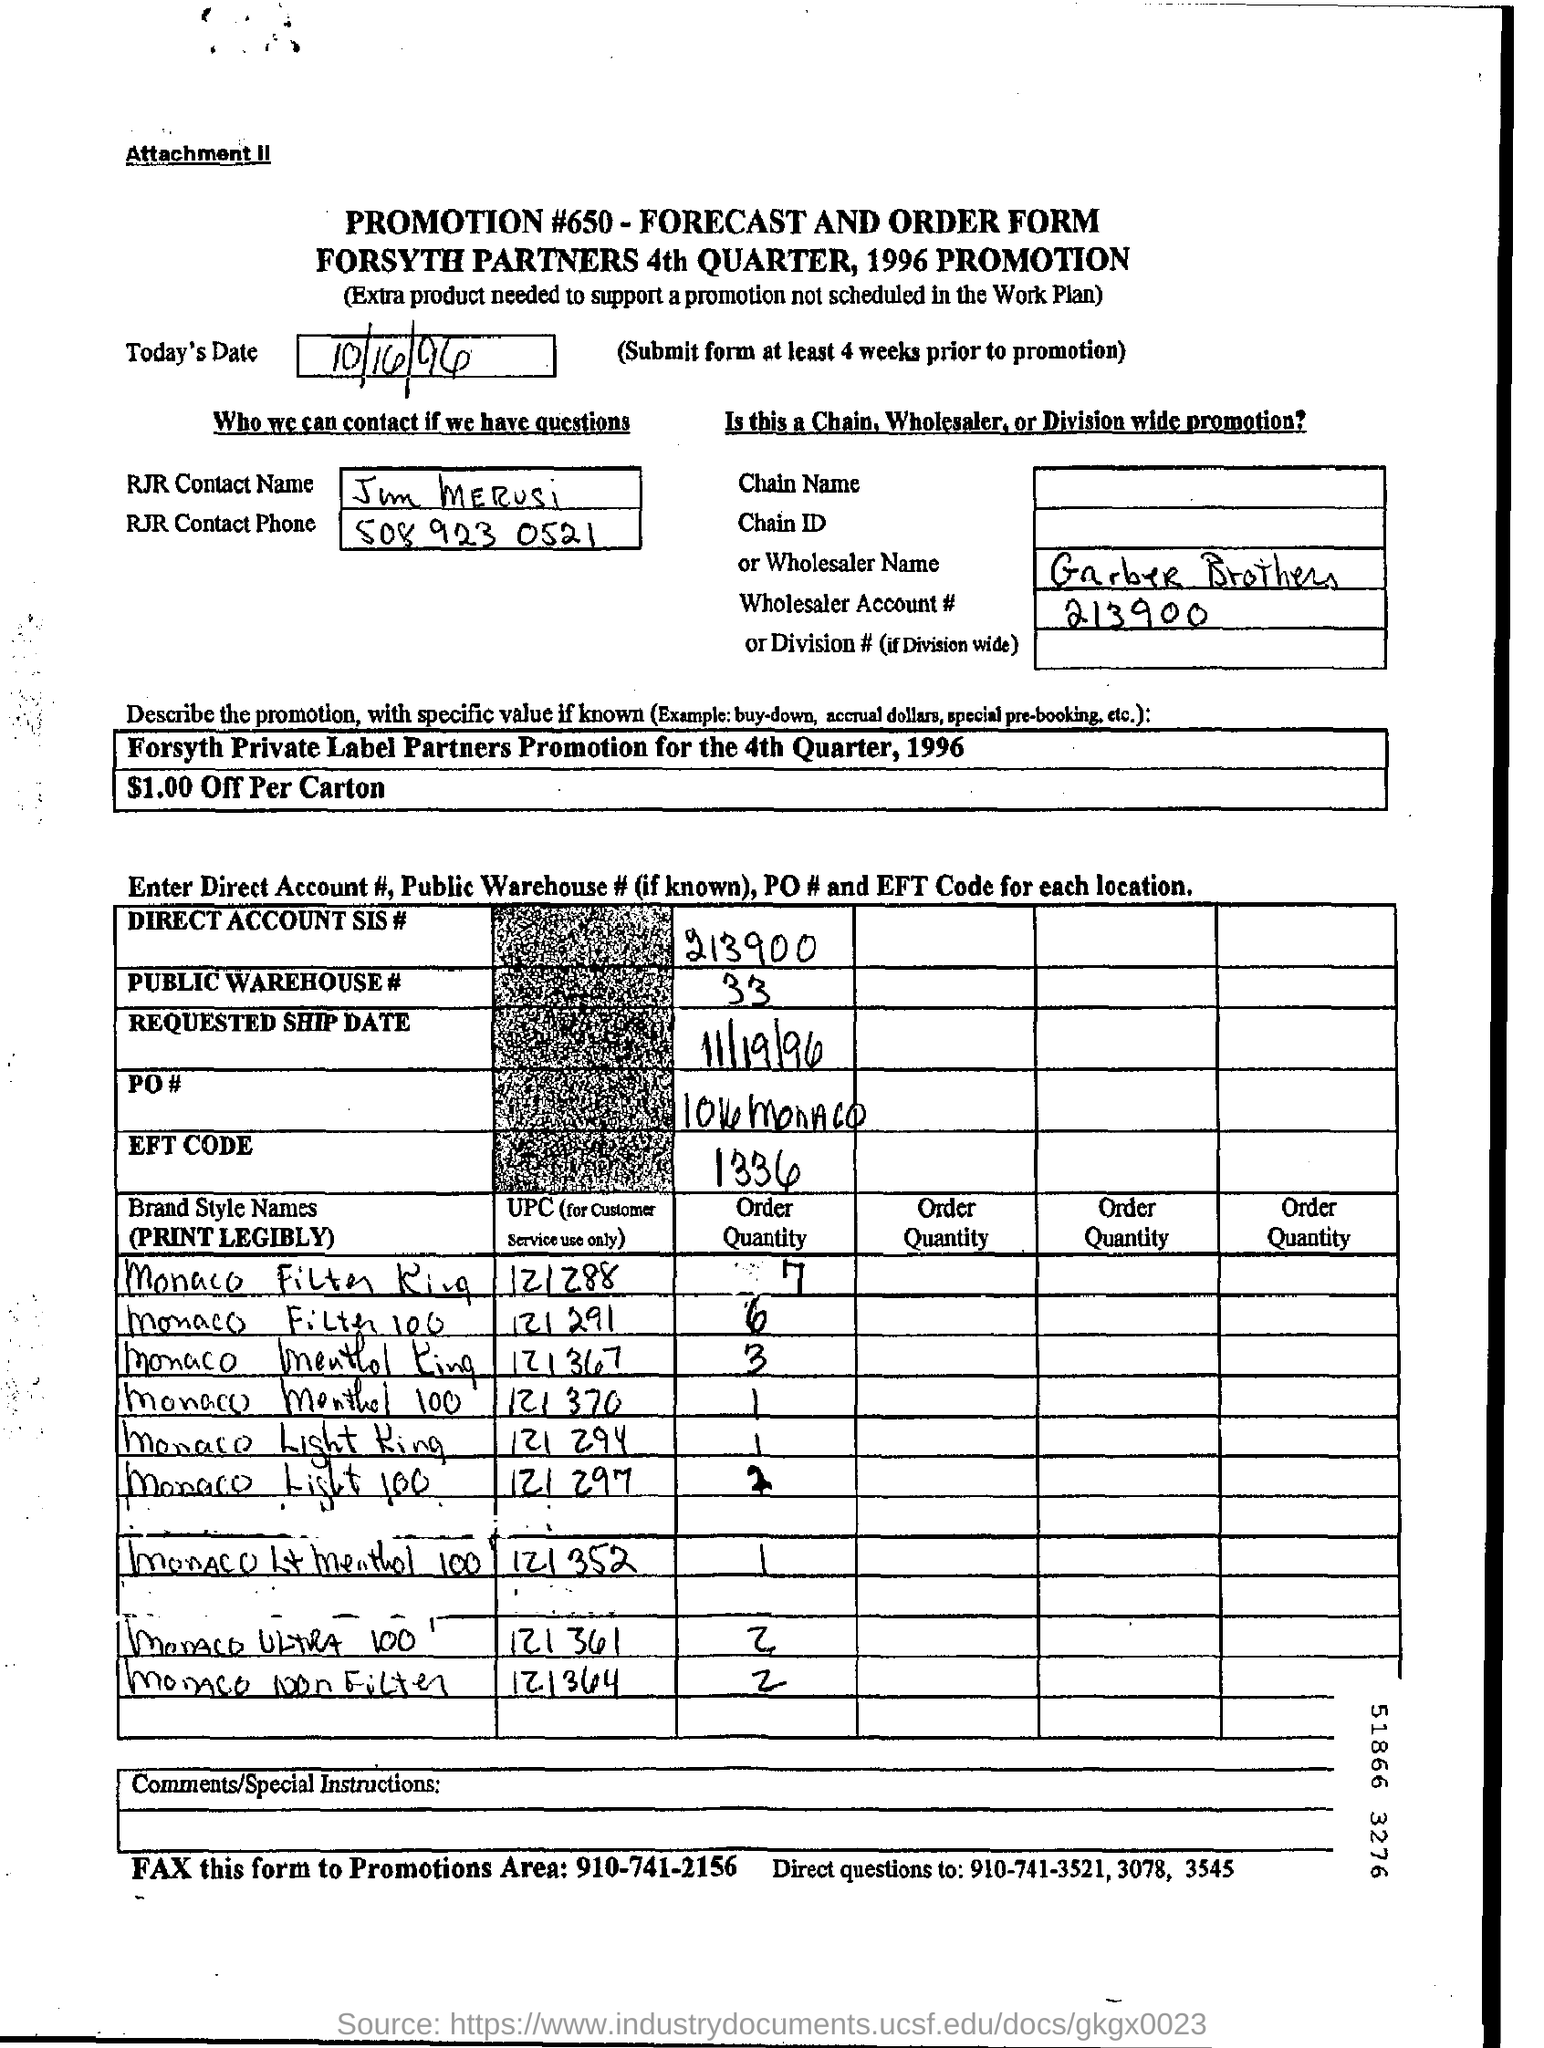What is the Wholesaler Account # ?
Offer a terse response. 213900. What is the DIRECT ACCOUNT SIS#?
Your answer should be compact. 213900. What is the EFT CODE?
Ensure brevity in your answer.  1336. What is the requested ship date?
Your answer should be very brief. 11/19/96. 